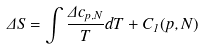Convert formula to latex. <formula><loc_0><loc_0><loc_500><loc_500>\Delta S = \int \frac { \Delta c _ { p , N } } T d T + C _ { 1 } ( p , N )</formula> 